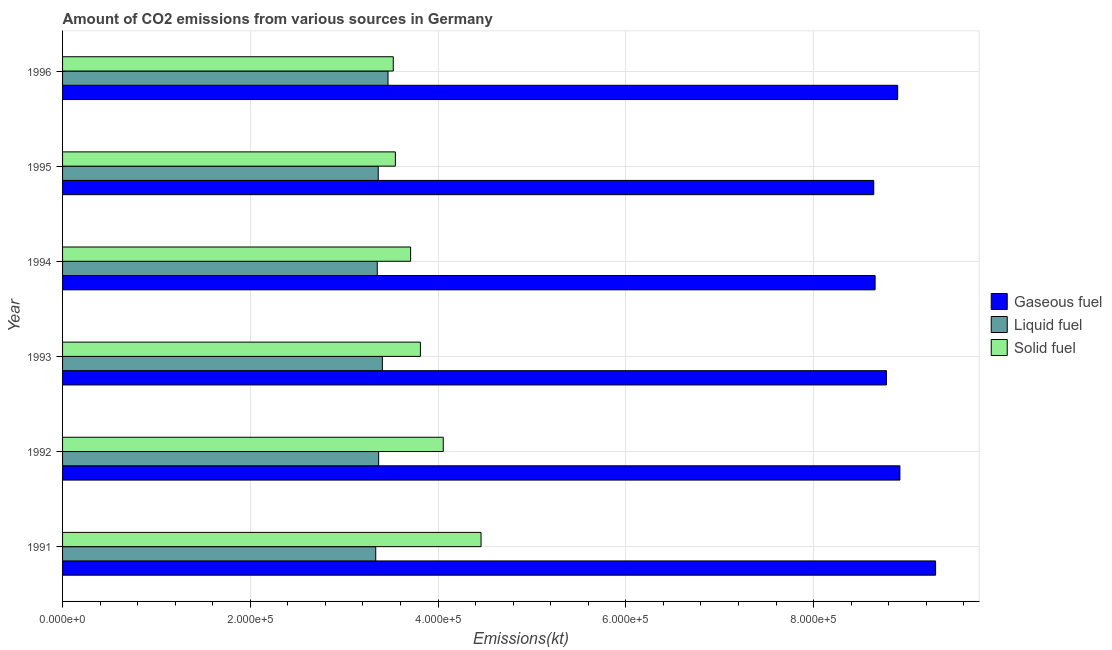How many different coloured bars are there?
Provide a succinct answer. 3. How many groups of bars are there?
Provide a succinct answer. 6. Are the number of bars per tick equal to the number of legend labels?
Make the answer very short. Yes. Are the number of bars on each tick of the Y-axis equal?
Provide a short and direct response. Yes. How many bars are there on the 2nd tick from the top?
Provide a short and direct response. 3. In how many cases, is the number of bars for a given year not equal to the number of legend labels?
Ensure brevity in your answer.  0. What is the amount of co2 emissions from solid fuel in 1994?
Offer a terse response. 3.71e+05. Across all years, what is the maximum amount of co2 emissions from solid fuel?
Give a very brief answer. 4.46e+05. Across all years, what is the minimum amount of co2 emissions from solid fuel?
Your answer should be compact. 3.52e+05. In which year was the amount of co2 emissions from solid fuel maximum?
Your answer should be very brief. 1991. In which year was the amount of co2 emissions from liquid fuel minimum?
Ensure brevity in your answer.  1991. What is the total amount of co2 emissions from gaseous fuel in the graph?
Give a very brief answer. 5.32e+06. What is the difference between the amount of co2 emissions from liquid fuel in 1995 and that in 1996?
Offer a terse response. -1.04e+04. What is the difference between the amount of co2 emissions from gaseous fuel in 1995 and the amount of co2 emissions from liquid fuel in 1994?
Your answer should be compact. 5.29e+05. What is the average amount of co2 emissions from gaseous fuel per year?
Provide a succinct answer. 8.86e+05. In the year 1992, what is the difference between the amount of co2 emissions from solid fuel and amount of co2 emissions from liquid fuel?
Give a very brief answer. 6.89e+04. In how many years, is the amount of co2 emissions from solid fuel greater than 240000 kt?
Keep it short and to the point. 6. What is the ratio of the amount of co2 emissions from gaseous fuel in 1991 to that in 1992?
Your response must be concise. 1.04. What is the difference between the highest and the second highest amount of co2 emissions from liquid fuel?
Your response must be concise. 6024.88. What is the difference between the highest and the lowest amount of co2 emissions from solid fuel?
Keep it short and to the point. 9.35e+04. What does the 3rd bar from the top in 1993 represents?
Keep it short and to the point. Gaseous fuel. What does the 1st bar from the bottom in 1994 represents?
Give a very brief answer. Gaseous fuel. Is it the case that in every year, the sum of the amount of co2 emissions from gaseous fuel and amount of co2 emissions from liquid fuel is greater than the amount of co2 emissions from solid fuel?
Your answer should be compact. Yes. Are all the bars in the graph horizontal?
Keep it short and to the point. Yes. How many years are there in the graph?
Your response must be concise. 6. Where does the legend appear in the graph?
Your answer should be compact. Center right. How many legend labels are there?
Provide a short and direct response. 3. What is the title of the graph?
Your response must be concise. Amount of CO2 emissions from various sources in Germany. Does "Natural Gas" appear as one of the legend labels in the graph?
Make the answer very short. No. What is the label or title of the X-axis?
Offer a terse response. Emissions(kt). What is the Emissions(kt) in Gaseous fuel in 1991?
Your answer should be compact. 9.30e+05. What is the Emissions(kt) in Liquid fuel in 1991?
Your answer should be compact. 3.34e+05. What is the Emissions(kt) in Solid fuel in 1991?
Your answer should be very brief. 4.46e+05. What is the Emissions(kt) of Gaseous fuel in 1992?
Keep it short and to the point. 8.92e+05. What is the Emissions(kt) of Liquid fuel in 1992?
Provide a short and direct response. 3.37e+05. What is the Emissions(kt) of Solid fuel in 1992?
Give a very brief answer. 4.06e+05. What is the Emissions(kt) in Gaseous fuel in 1993?
Provide a succinct answer. 8.78e+05. What is the Emissions(kt) in Liquid fuel in 1993?
Provide a short and direct response. 3.41e+05. What is the Emissions(kt) of Solid fuel in 1993?
Provide a short and direct response. 3.81e+05. What is the Emissions(kt) in Gaseous fuel in 1994?
Give a very brief answer. 8.66e+05. What is the Emissions(kt) of Liquid fuel in 1994?
Your response must be concise. 3.35e+05. What is the Emissions(kt) of Solid fuel in 1994?
Make the answer very short. 3.71e+05. What is the Emissions(kt) of Gaseous fuel in 1995?
Provide a short and direct response. 8.64e+05. What is the Emissions(kt) in Liquid fuel in 1995?
Keep it short and to the point. 3.36e+05. What is the Emissions(kt) in Solid fuel in 1995?
Your answer should be very brief. 3.55e+05. What is the Emissions(kt) of Gaseous fuel in 1996?
Keep it short and to the point. 8.90e+05. What is the Emissions(kt) of Liquid fuel in 1996?
Give a very brief answer. 3.47e+05. What is the Emissions(kt) of Solid fuel in 1996?
Your answer should be very brief. 3.52e+05. Across all years, what is the maximum Emissions(kt) of Gaseous fuel?
Give a very brief answer. 9.30e+05. Across all years, what is the maximum Emissions(kt) in Liquid fuel?
Your response must be concise. 3.47e+05. Across all years, what is the maximum Emissions(kt) of Solid fuel?
Your answer should be very brief. 4.46e+05. Across all years, what is the minimum Emissions(kt) of Gaseous fuel?
Your response must be concise. 8.64e+05. Across all years, what is the minimum Emissions(kt) in Liquid fuel?
Ensure brevity in your answer.  3.34e+05. Across all years, what is the minimum Emissions(kt) in Solid fuel?
Keep it short and to the point. 3.52e+05. What is the total Emissions(kt) in Gaseous fuel in the graph?
Your answer should be very brief. 5.32e+06. What is the total Emissions(kt) in Liquid fuel in the graph?
Give a very brief answer. 2.03e+06. What is the total Emissions(kt) in Solid fuel in the graph?
Your answer should be very brief. 2.31e+06. What is the difference between the Emissions(kt) in Gaseous fuel in 1991 and that in 1992?
Offer a very short reply. 3.80e+04. What is the difference between the Emissions(kt) of Liquid fuel in 1991 and that in 1992?
Your response must be concise. -3072.95. What is the difference between the Emissions(kt) in Solid fuel in 1991 and that in 1992?
Give a very brief answer. 4.02e+04. What is the difference between the Emissions(kt) in Gaseous fuel in 1991 and that in 1993?
Offer a terse response. 5.23e+04. What is the difference between the Emissions(kt) of Liquid fuel in 1991 and that in 1993?
Your answer should be compact. -7044.31. What is the difference between the Emissions(kt) in Solid fuel in 1991 and that in 1993?
Your answer should be compact. 6.46e+04. What is the difference between the Emissions(kt) in Gaseous fuel in 1991 and that in 1994?
Give a very brief answer. 6.44e+04. What is the difference between the Emissions(kt) in Liquid fuel in 1991 and that in 1994?
Offer a very short reply. -1602.48. What is the difference between the Emissions(kt) of Solid fuel in 1991 and that in 1994?
Give a very brief answer. 7.50e+04. What is the difference between the Emissions(kt) of Gaseous fuel in 1991 and that in 1995?
Offer a terse response. 6.59e+04. What is the difference between the Emissions(kt) in Liquid fuel in 1991 and that in 1995?
Provide a succinct answer. -2640.24. What is the difference between the Emissions(kt) of Solid fuel in 1991 and that in 1995?
Ensure brevity in your answer.  9.13e+04. What is the difference between the Emissions(kt) of Gaseous fuel in 1991 and that in 1996?
Your answer should be compact. 4.04e+04. What is the difference between the Emissions(kt) of Liquid fuel in 1991 and that in 1996?
Make the answer very short. -1.31e+04. What is the difference between the Emissions(kt) in Solid fuel in 1991 and that in 1996?
Ensure brevity in your answer.  9.35e+04. What is the difference between the Emissions(kt) in Gaseous fuel in 1992 and that in 1993?
Ensure brevity in your answer.  1.43e+04. What is the difference between the Emissions(kt) of Liquid fuel in 1992 and that in 1993?
Provide a short and direct response. -3971.36. What is the difference between the Emissions(kt) in Solid fuel in 1992 and that in 1993?
Give a very brief answer. 2.44e+04. What is the difference between the Emissions(kt) in Gaseous fuel in 1992 and that in 1994?
Your answer should be compact. 2.64e+04. What is the difference between the Emissions(kt) in Liquid fuel in 1992 and that in 1994?
Ensure brevity in your answer.  1470.47. What is the difference between the Emissions(kt) in Solid fuel in 1992 and that in 1994?
Your answer should be compact. 3.48e+04. What is the difference between the Emissions(kt) of Gaseous fuel in 1992 and that in 1995?
Your answer should be compact. 2.79e+04. What is the difference between the Emissions(kt) of Liquid fuel in 1992 and that in 1995?
Keep it short and to the point. 432.71. What is the difference between the Emissions(kt) in Solid fuel in 1992 and that in 1995?
Make the answer very short. 5.10e+04. What is the difference between the Emissions(kt) of Gaseous fuel in 1992 and that in 1996?
Keep it short and to the point. 2361.55. What is the difference between the Emissions(kt) in Liquid fuel in 1992 and that in 1996?
Your answer should be compact. -9996.24. What is the difference between the Emissions(kt) of Solid fuel in 1992 and that in 1996?
Your answer should be very brief. 5.33e+04. What is the difference between the Emissions(kt) in Gaseous fuel in 1993 and that in 1994?
Offer a terse response. 1.21e+04. What is the difference between the Emissions(kt) of Liquid fuel in 1993 and that in 1994?
Your answer should be very brief. 5441.83. What is the difference between the Emissions(kt) in Solid fuel in 1993 and that in 1994?
Make the answer very short. 1.04e+04. What is the difference between the Emissions(kt) of Gaseous fuel in 1993 and that in 1995?
Give a very brief answer. 1.35e+04. What is the difference between the Emissions(kt) in Liquid fuel in 1993 and that in 1995?
Provide a short and direct response. 4404.07. What is the difference between the Emissions(kt) in Solid fuel in 1993 and that in 1995?
Make the answer very short. 2.67e+04. What is the difference between the Emissions(kt) in Gaseous fuel in 1993 and that in 1996?
Ensure brevity in your answer.  -1.20e+04. What is the difference between the Emissions(kt) of Liquid fuel in 1993 and that in 1996?
Keep it short and to the point. -6024.88. What is the difference between the Emissions(kt) in Solid fuel in 1993 and that in 1996?
Give a very brief answer. 2.89e+04. What is the difference between the Emissions(kt) in Gaseous fuel in 1994 and that in 1995?
Your answer should be very brief. 1448.46. What is the difference between the Emissions(kt) of Liquid fuel in 1994 and that in 1995?
Give a very brief answer. -1037.76. What is the difference between the Emissions(kt) of Solid fuel in 1994 and that in 1995?
Ensure brevity in your answer.  1.62e+04. What is the difference between the Emissions(kt) of Gaseous fuel in 1994 and that in 1996?
Offer a very short reply. -2.41e+04. What is the difference between the Emissions(kt) in Liquid fuel in 1994 and that in 1996?
Offer a terse response. -1.15e+04. What is the difference between the Emissions(kt) of Solid fuel in 1994 and that in 1996?
Give a very brief answer. 1.85e+04. What is the difference between the Emissions(kt) of Gaseous fuel in 1995 and that in 1996?
Keep it short and to the point. -2.55e+04. What is the difference between the Emissions(kt) of Liquid fuel in 1995 and that in 1996?
Your answer should be compact. -1.04e+04. What is the difference between the Emissions(kt) of Solid fuel in 1995 and that in 1996?
Provide a short and direct response. 2244.2. What is the difference between the Emissions(kt) of Gaseous fuel in 1991 and the Emissions(kt) of Liquid fuel in 1992?
Give a very brief answer. 5.93e+05. What is the difference between the Emissions(kt) of Gaseous fuel in 1991 and the Emissions(kt) of Solid fuel in 1992?
Make the answer very short. 5.24e+05. What is the difference between the Emissions(kt) of Liquid fuel in 1991 and the Emissions(kt) of Solid fuel in 1992?
Give a very brief answer. -7.19e+04. What is the difference between the Emissions(kt) in Gaseous fuel in 1991 and the Emissions(kt) in Liquid fuel in 1993?
Provide a succinct answer. 5.89e+05. What is the difference between the Emissions(kt) in Gaseous fuel in 1991 and the Emissions(kt) in Solid fuel in 1993?
Offer a very short reply. 5.49e+05. What is the difference between the Emissions(kt) of Liquid fuel in 1991 and the Emissions(kt) of Solid fuel in 1993?
Keep it short and to the point. -4.76e+04. What is the difference between the Emissions(kt) in Gaseous fuel in 1991 and the Emissions(kt) in Liquid fuel in 1994?
Provide a succinct answer. 5.95e+05. What is the difference between the Emissions(kt) of Gaseous fuel in 1991 and the Emissions(kt) of Solid fuel in 1994?
Keep it short and to the point. 5.59e+05. What is the difference between the Emissions(kt) of Liquid fuel in 1991 and the Emissions(kt) of Solid fuel in 1994?
Make the answer very short. -3.71e+04. What is the difference between the Emissions(kt) of Gaseous fuel in 1991 and the Emissions(kt) of Liquid fuel in 1995?
Provide a succinct answer. 5.94e+05. What is the difference between the Emissions(kt) of Gaseous fuel in 1991 and the Emissions(kt) of Solid fuel in 1995?
Provide a succinct answer. 5.75e+05. What is the difference between the Emissions(kt) of Liquid fuel in 1991 and the Emissions(kt) of Solid fuel in 1995?
Keep it short and to the point. -2.09e+04. What is the difference between the Emissions(kt) of Gaseous fuel in 1991 and the Emissions(kt) of Liquid fuel in 1996?
Keep it short and to the point. 5.83e+05. What is the difference between the Emissions(kt) in Gaseous fuel in 1991 and the Emissions(kt) in Solid fuel in 1996?
Keep it short and to the point. 5.78e+05. What is the difference between the Emissions(kt) of Liquid fuel in 1991 and the Emissions(kt) of Solid fuel in 1996?
Your answer should be very brief. -1.87e+04. What is the difference between the Emissions(kt) in Gaseous fuel in 1992 and the Emissions(kt) in Liquid fuel in 1993?
Give a very brief answer. 5.51e+05. What is the difference between the Emissions(kt) of Gaseous fuel in 1992 and the Emissions(kt) of Solid fuel in 1993?
Offer a very short reply. 5.11e+05. What is the difference between the Emissions(kt) of Liquid fuel in 1992 and the Emissions(kt) of Solid fuel in 1993?
Ensure brevity in your answer.  -4.45e+04. What is the difference between the Emissions(kt) in Gaseous fuel in 1992 and the Emissions(kt) in Liquid fuel in 1994?
Offer a very short reply. 5.57e+05. What is the difference between the Emissions(kt) in Gaseous fuel in 1992 and the Emissions(kt) in Solid fuel in 1994?
Your answer should be very brief. 5.21e+05. What is the difference between the Emissions(kt) in Liquid fuel in 1992 and the Emissions(kt) in Solid fuel in 1994?
Your response must be concise. -3.41e+04. What is the difference between the Emissions(kt) of Gaseous fuel in 1992 and the Emissions(kt) of Liquid fuel in 1995?
Offer a very short reply. 5.56e+05. What is the difference between the Emissions(kt) of Gaseous fuel in 1992 and the Emissions(kt) of Solid fuel in 1995?
Offer a terse response. 5.37e+05. What is the difference between the Emissions(kt) in Liquid fuel in 1992 and the Emissions(kt) in Solid fuel in 1995?
Provide a short and direct response. -1.78e+04. What is the difference between the Emissions(kt) of Gaseous fuel in 1992 and the Emissions(kt) of Liquid fuel in 1996?
Keep it short and to the point. 5.45e+05. What is the difference between the Emissions(kt) of Gaseous fuel in 1992 and the Emissions(kt) of Solid fuel in 1996?
Ensure brevity in your answer.  5.40e+05. What is the difference between the Emissions(kt) of Liquid fuel in 1992 and the Emissions(kt) of Solid fuel in 1996?
Provide a succinct answer. -1.56e+04. What is the difference between the Emissions(kt) in Gaseous fuel in 1993 and the Emissions(kt) in Liquid fuel in 1994?
Your answer should be very brief. 5.42e+05. What is the difference between the Emissions(kt) in Gaseous fuel in 1993 and the Emissions(kt) in Solid fuel in 1994?
Provide a short and direct response. 5.07e+05. What is the difference between the Emissions(kt) of Liquid fuel in 1993 and the Emissions(kt) of Solid fuel in 1994?
Offer a terse response. -3.01e+04. What is the difference between the Emissions(kt) of Gaseous fuel in 1993 and the Emissions(kt) of Liquid fuel in 1995?
Make the answer very short. 5.41e+05. What is the difference between the Emissions(kt) of Gaseous fuel in 1993 and the Emissions(kt) of Solid fuel in 1995?
Your answer should be compact. 5.23e+05. What is the difference between the Emissions(kt) in Liquid fuel in 1993 and the Emissions(kt) in Solid fuel in 1995?
Provide a succinct answer. -1.39e+04. What is the difference between the Emissions(kt) of Gaseous fuel in 1993 and the Emissions(kt) of Liquid fuel in 1996?
Ensure brevity in your answer.  5.31e+05. What is the difference between the Emissions(kt) in Gaseous fuel in 1993 and the Emissions(kt) in Solid fuel in 1996?
Ensure brevity in your answer.  5.25e+05. What is the difference between the Emissions(kt) in Liquid fuel in 1993 and the Emissions(kt) in Solid fuel in 1996?
Your answer should be compact. -1.16e+04. What is the difference between the Emissions(kt) of Gaseous fuel in 1994 and the Emissions(kt) of Liquid fuel in 1995?
Offer a terse response. 5.29e+05. What is the difference between the Emissions(kt) in Gaseous fuel in 1994 and the Emissions(kt) in Solid fuel in 1995?
Keep it short and to the point. 5.11e+05. What is the difference between the Emissions(kt) of Liquid fuel in 1994 and the Emissions(kt) of Solid fuel in 1995?
Offer a terse response. -1.93e+04. What is the difference between the Emissions(kt) of Gaseous fuel in 1994 and the Emissions(kt) of Liquid fuel in 1996?
Keep it short and to the point. 5.19e+05. What is the difference between the Emissions(kt) in Gaseous fuel in 1994 and the Emissions(kt) in Solid fuel in 1996?
Give a very brief answer. 5.13e+05. What is the difference between the Emissions(kt) of Liquid fuel in 1994 and the Emissions(kt) of Solid fuel in 1996?
Provide a short and direct response. -1.71e+04. What is the difference between the Emissions(kt) of Gaseous fuel in 1995 and the Emissions(kt) of Liquid fuel in 1996?
Give a very brief answer. 5.17e+05. What is the difference between the Emissions(kt) of Gaseous fuel in 1995 and the Emissions(kt) of Solid fuel in 1996?
Provide a succinct answer. 5.12e+05. What is the difference between the Emissions(kt) of Liquid fuel in 1995 and the Emissions(kt) of Solid fuel in 1996?
Offer a terse response. -1.60e+04. What is the average Emissions(kt) of Gaseous fuel per year?
Give a very brief answer. 8.86e+05. What is the average Emissions(kt) in Liquid fuel per year?
Provide a succinct answer. 3.38e+05. What is the average Emissions(kt) of Solid fuel per year?
Offer a very short reply. 3.85e+05. In the year 1991, what is the difference between the Emissions(kt) of Gaseous fuel and Emissions(kt) of Liquid fuel?
Make the answer very short. 5.96e+05. In the year 1991, what is the difference between the Emissions(kt) in Gaseous fuel and Emissions(kt) in Solid fuel?
Keep it short and to the point. 4.84e+05. In the year 1991, what is the difference between the Emissions(kt) of Liquid fuel and Emissions(kt) of Solid fuel?
Provide a succinct answer. -1.12e+05. In the year 1992, what is the difference between the Emissions(kt) of Gaseous fuel and Emissions(kt) of Liquid fuel?
Give a very brief answer. 5.55e+05. In the year 1992, what is the difference between the Emissions(kt) of Gaseous fuel and Emissions(kt) of Solid fuel?
Ensure brevity in your answer.  4.86e+05. In the year 1992, what is the difference between the Emissions(kt) of Liquid fuel and Emissions(kt) of Solid fuel?
Give a very brief answer. -6.89e+04. In the year 1993, what is the difference between the Emissions(kt) of Gaseous fuel and Emissions(kt) of Liquid fuel?
Your response must be concise. 5.37e+05. In the year 1993, what is the difference between the Emissions(kt) of Gaseous fuel and Emissions(kt) of Solid fuel?
Provide a succinct answer. 4.96e+05. In the year 1993, what is the difference between the Emissions(kt) in Liquid fuel and Emissions(kt) in Solid fuel?
Your answer should be compact. -4.05e+04. In the year 1994, what is the difference between the Emissions(kt) of Gaseous fuel and Emissions(kt) of Liquid fuel?
Keep it short and to the point. 5.30e+05. In the year 1994, what is the difference between the Emissions(kt) of Gaseous fuel and Emissions(kt) of Solid fuel?
Your response must be concise. 4.95e+05. In the year 1994, what is the difference between the Emissions(kt) of Liquid fuel and Emissions(kt) of Solid fuel?
Your response must be concise. -3.55e+04. In the year 1995, what is the difference between the Emissions(kt) in Gaseous fuel and Emissions(kt) in Liquid fuel?
Keep it short and to the point. 5.28e+05. In the year 1995, what is the difference between the Emissions(kt) in Gaseous fuel and Emissions(kt) in Solid fuel?
Offer a terse response. 5.10e+05. In the year 1995, what is the difference between the Emissions(kt) of Liquid fuel and Emissions(kt) of Solid fuel?
Provide a succinct answer. -1.83e+04. In the year 1996, what is the difference between the Emissions(kt) in Gaseous fuel and Emissions(kt) in Liquid fuel?
Your answer should be very brief. 5.43e+05. In the year 1996, what is the difference between the Emissions(kt) of Gaseous fuel and Emissions(kt) of Solid fuel?
Your answer should be compact. 5.37e+05. In the year 1996, what is the difference between the Emissions(kt) in Liquid fuel and Emissions(kt) in Solid fuel?
Make the answer very short. -5588.51. What is the ratio of the Emissions(kt) of Gaseous fuel in 1991 to that in 1992?
Provide a short and direct response. 1.04. What is the ratio of the Emissions(kt) of Liquid fuel in 1991 to that in 1992?
Your response must be concise. 0.99. What is the ratio of the Emissions(kt) of Solid fuel in 1991 to that in 1992?
Make the answer very short. 1.1. What is the ratio of the Emissions(kt) of Gaseous fuel in 1991 to that in 1993?
Your answer should be very brief. 1.06. What is the ratio of the Emissions(kt) of Liquid fuel in 1991 to that in 1993?
Your answer should be compact. 0.98. What is the ratio of the Emissions(kt) of Solid fuel in 1991 to that in 1993?
Give a very brief answer. 1.17. What is the ratio of the Emissions(kt) in Gaseous fuel in 1991 to that in 1994?
Your answer should be compact. 1.07. What is the ratio of the Emissions(kt) in Solid fuel in 1991 to that in 1994?
Provide a short and direct response. 1.2. What is the ratio of the Emissions(kt) of Gaseous fuel in 1991 to that in 1995?
Ensure brevity in your answer.  1.08. What is the ratio of the Emissions(kt) in Solid fuel in 1991 to that in 1995?
Ensure brevity in your answer.  1.26. What is the ratio of the Emissions(kt) in Gaseous fuel in 1991 to that in 1996?
Provide a succinct answer. 1.05. What is the ratio of the Emissions(kt) in Liquid fuel in 1991 to that in 1996?
Ensure brevity in your answer.  0.96. What is the ratio of the Emissions(kt) in Solid fuel in 1991 to that in 1996?
Your answer should be very brief. 1.27. What is the ratio of the Emissions(kt) of Gaseous fuel in 1992 to that in 1993?
Make the answer very short. 1.02. What is the ratio of the Emissions(kt) of Liquid fuel in 1992 to that in 1993?
Provide a succinct answer. 0.99. What is the ratio of the Emissions(kt) of Solid fuel in 1992 to that in 1993?
Provide a succinct answer. 1.06. What is the ratio of the Emissions(kt) of Gaseous fuel in 1992 to that in 1994?
Ensure brevity in your answer.  1.03. What is the ratio of the Emissions(kt) of Liquid fuel in 1992 to that in 1994?
Your answer should be very brief. 1. What is the ratio of the Emissions(kt) of Solid fuel in 1992 to that in 1994?
Your response must be concise. 1.09. What is the ratio of the Emissions(kt) of Gaseous fuel in 1992 to that in 1995?
Provide a succinct answer. 1.03. What is the ratio of the Emissions(kt) in Solid fuel in 1992 to that in 1995?
Your response must be concise. 1.14. What is the ratio of the Emissions(kt) of Liquid fuel in 1992 to that in 1996?
Offer a very short reply. 0.97. What is the ratio of the Emissions(kt) of Solid fuel in 1992 to that in 1996?
Your answer should be very brief. 1.15. What is the ratio of the Emissions(kt) of Gaseous fuel in 1993 to that in 1994?
Provide a succinct answer. 1.01. What is the ratio of the Emissions(kt) of Liquid fuel in 1993 to that in 1994?
Give a very brief answer. 1.02. What is the ratio of the Emissions(kt) of Solid fuel in 1993 to that in 1994?
Provide a short and direct response. 1.03. What is the ratio of the Emissions(kt) of Gaseous fuel in 1993 to that in 1995?
Give a very brief answer. 1.02. What is the ratio of the Emissions(kt) of Liquid fuel in 1993 to that in 1995?
Your answer should be compact. 1.01. What is the ratio of the Emissions(kt) of Solid fuel in 1993 to that in 1995?
Provide a succinct answer. 1.08. What is the ratio of the Emissions(kt) in Gaseous fuel in 1993 to that in 1996?
Your answer should be compact. 0.99. What is the ratio of the Emissions(kt) of Liquid fuel in 1993 to that in 1996?
Your answer should be very brief. 0.98. What is the ratio of the Emissions(kt) of Solid fuel in 1993 to that in 1996?
Provide a short and direct response. 1.08. What is the ratio of the Emissions(kt) in Gaseous fuel in 1994 to that in 1995?
Provide a succinct answer. 1. What is the ratio of the Emissions(kt) of Liquid fuel in 1994 to that in 1995?
Your answer should be compact. 1. What is the ratio of the Emissions(kt) of Solid fuel in 1994 to that in 1995?
Offer a very short reply. 1.05. What is the ratio of the Emissions(kt) of Liquid fuel in 1994 to that in 1996?
Make the answer very short. 0.97. What is the ratio of the Emissions(kt) in Solid fuel in 1994 to that in 1996?
Give a very brief answer. 1.05. What is the ratio of the Emissions(kt) of Gaseous fuel in 1995 to that in 1996?
Ensure brevity in your answer.  0.97. What is the ratio of the Emissions(kt) of Liquid fuel in 1995 to that in 1996?
Give a very brief answer. 0.97. What is the ratio of the Emissions(kt) in Solid fuel in 1995 to that in 1996?
Give a very brief answer. 1.01. What is the difference between the highest and the second highest Emissions(kt) in Gaseous fuel?
Ensure brevity in your answer.  3.80e+04. What is the difference between the highest and the second highest Emissions(kt) of Liquid fuel?
Your answer should be very brief. 6024.88. What is the difference between the highest and the second highest Emissions(kt) in Solid fuel?
Make the answer very short. 4.02e+04. What is the difference between the highest and the lowest Emissions(kt) of Gaseous fuel?
Ensure brevity in your answer.  6.59e+04. What is the difference between the highest and the lowest Emissions(kt) of Liquid fuel?
Provide a succinct answer. 1.31e+04. What is the difference between the highest and the lowest Emissions(kt) in Solid fuel?
Offer a very short reply. 9.35e+04. 